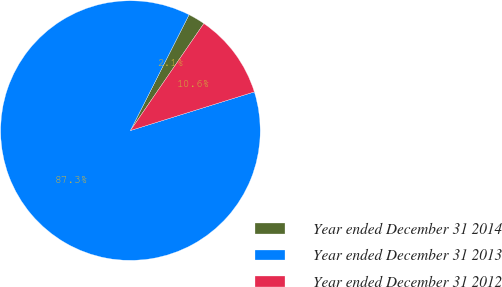Convert chart. <chart><loc_0><loc_0><loc_500><loc_500><pie_chart><fcel>Year ended December 31 2014<fcel>Year ended December 31 2013<fcel>Year ended December 31 2012<nl><fcel>2.11%<fcel>87.27%<fcel>10.62%<nl></chart> 